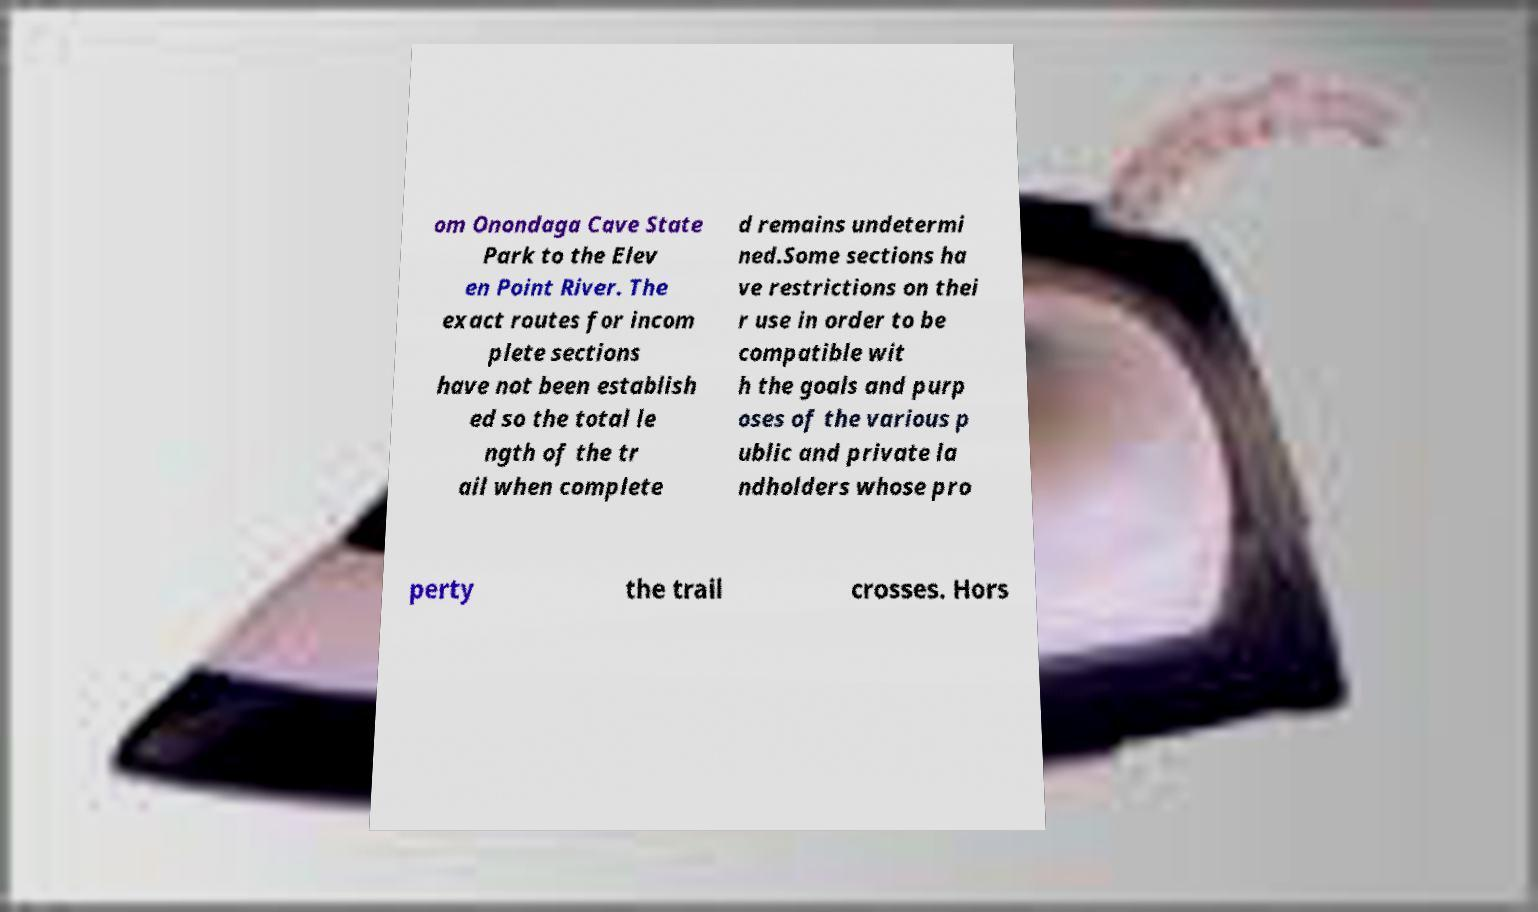For documentation purposes, I need the text within this image transcribed. Could you provide that? om Onondaga Cave State Park to the Elev en Point River. The exact routes for incom plete sections have not been establish ed so the total le ngth of the tr ail when complete d remains undetermi ned.Some sections ha ve restrictions on thei r use in order to be compatible wit h the goals and purp oses of the various p ublic and private la ndholders whose pro perty the trail crosses. Hors 